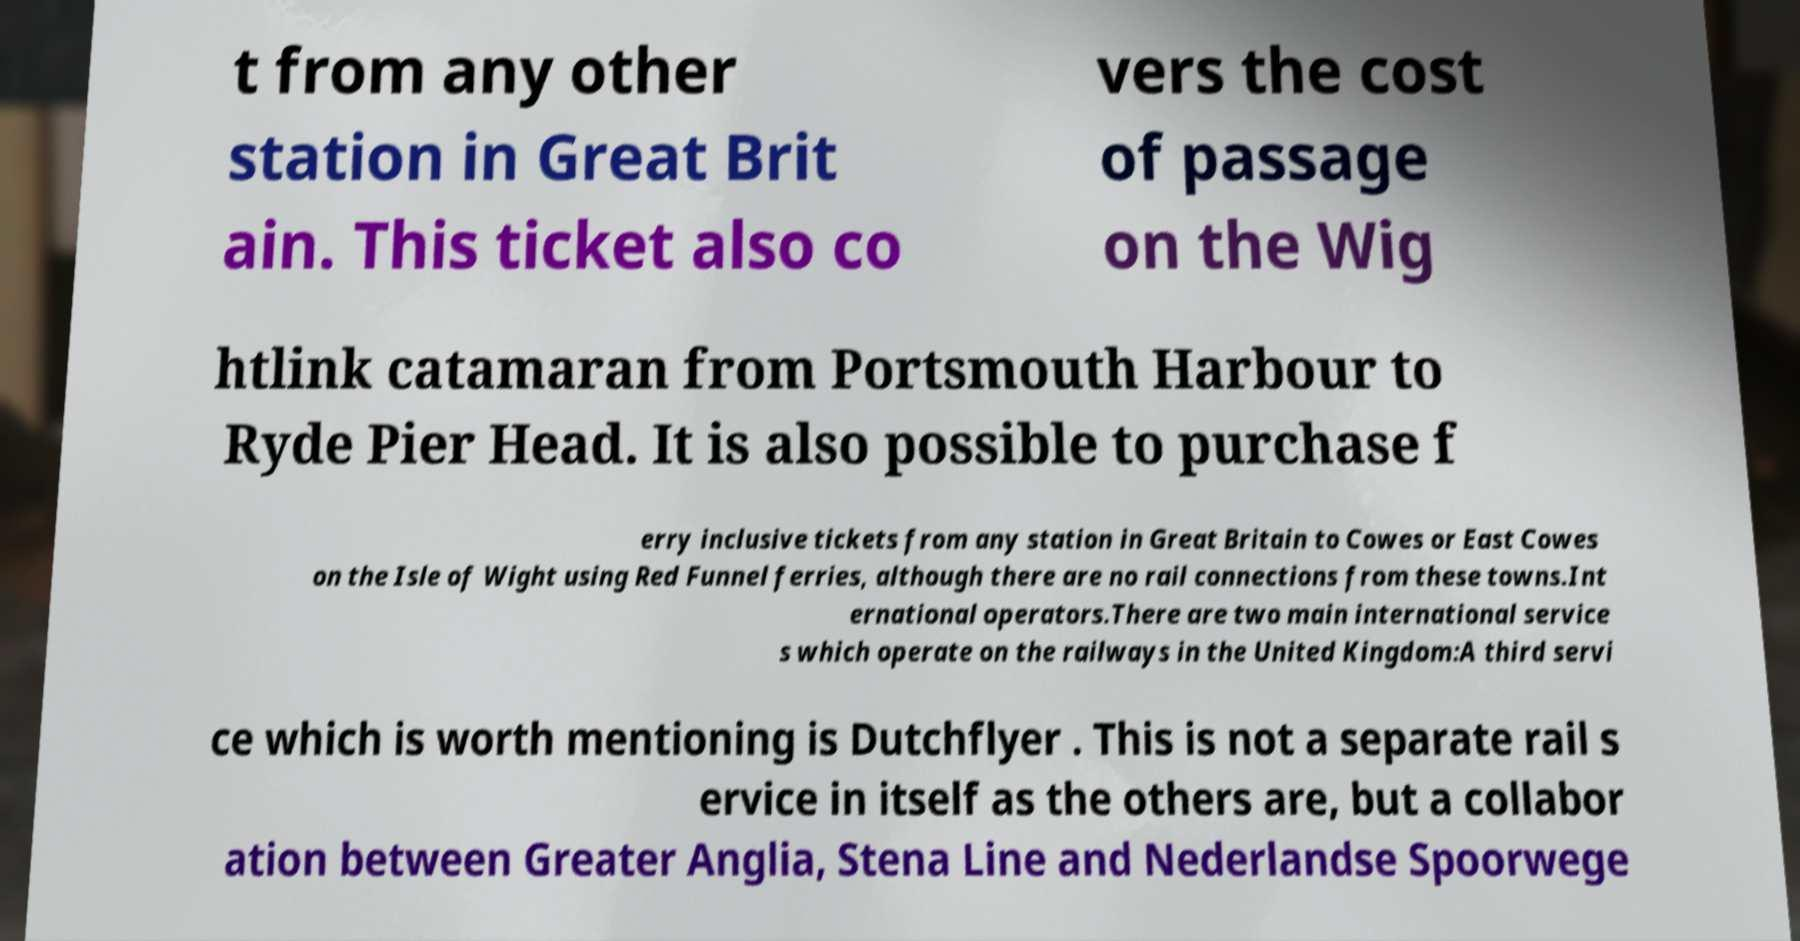There's text embedded in this image that I need extracted. Can you transcribe it verbatim? t from any other station in Great Brit ain. This ticket also co vers the cost of passage on the Wig htlink catamaran from Portsmouth Harbour to Ryde Pier Head. It is also possible to purchase f erry inclusive tickets from any station in Great Britain to Cowes or East Cowes on the Isle of Wight using Red Funnel ferries, although there are no rail connections from these towns.Int ernational operators.There are two main international service s which operate on the railways in the United Kingdom:A third servi ce which is worth mentioning is Dutchflyer . This is not a separate rail s ervice in itself as the others are, but a collabor ation between Greater Anglia, Stena Line and Nederlandse Spoorwege 